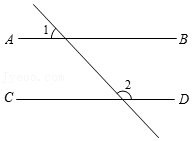Let's delve into another interesting aspect of this diagram. If another line, EF, intersects line AB at point E and line CD at point F, making an angle of 45° with AB, what would be the measure of the angle formed between EF and CD? Assuming line EF forms a 45° angle with AB and considering AB is parallel to CD, line EF will also form a 45° angle with CD because corresponding angles are equal when a line crosses two parallel lines. Therefore, the angle between EF and CD will also be 45°. 